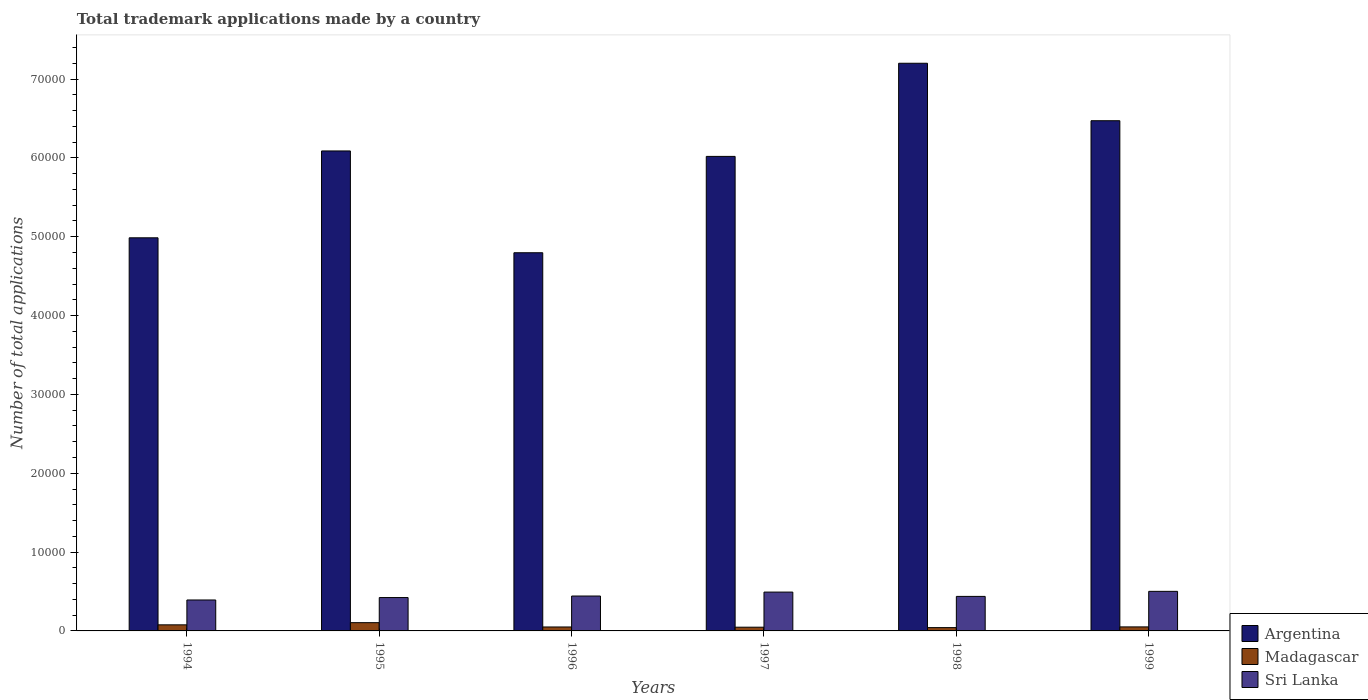How many groups of bars are there?
Make the answer very short. 6. Are the number of bars per tick equal to the number of legend labels?
Your answer should be very brief. Yes. Are the number of bars on each tick of the X-axis equal?
Provide a short and direct response. Yes. How many bars are there on the 2nd tick from the left?
Give a very brief answer. 3. What is the label of the 5th group of bars from the left?
Offer a terse response. 1998. In how many cases, is the number of bars for a given year not equal to the number of legend labels?
Your answer should be very brief. 0. Across all years, what is the maximum number of applications made by in Argentina?
Keep it short and to the point. 7.20e+04. Across all years, what is the minimum number of applications made by in Madagascar?
Ensure brevity in your answer.  420. In which year was the number of applications made by in Sri Lanka minimum?
Your response must be concise. 1994. What is the total number of applications made by in Argentina in the graph?
Your answer should be compact. 3.56e+05. What is the difference between the number of applications made by in Sri Lanka in 1994 and that in 1997?
Make the answer very short. -1001. What is the difference between the number of applications made by in Sri Lanka in 1994 and the number of applications made by in Madagascar in 1995?
Your answer should be compact. 2877. What is the average number of applications made by in Madagascar per year?
Keep it short and to the point. 620.33. In the year 1994, what is the difference between the number of applications made by in Sri Lanka and number of applications made by in Madagascar?
Offer a terse response. 3154. In how many years, is the number of applications made by in Madagascar greater than 48000?
Ensure brevity in your answer.  0. What is the ratio of the number of applications made by in Argentina in 1996 to that in 1998?
Make the answer very short. 0.67. Is the number of applications made by in Sri Lanka in 1997 less than that in 1998?
Provide a succinct answer. No. Is the difference between the number of applications made by in Sri Lanka in 1995 and 1996 greater than the difference between the number of applications made by in Madagascar in 1995 and 1996?
Your response must be concise. No. What is the difference between the highest and the second highest number of applications made by in Argentina?
Give a very brief answer. 7289. What is the difference between the highest and the lowest number of applications made by in Argentina?
Make the answer very short. 2.40e+04. In how many years, is the number of applications made by in Sri Lanka greater than the average number of applications made by in Sri Lanka taken over all years?
Your answer should be compact. 2. Is the sum of the number of applications made by in Sri Lanka in 1998 and 1999 greater than the maximum number of applications made by in Argentina across all years?
Offer a very short reply. No. What does the 3rd bar from the left in 1999 represents?
Your response must be concise. Sri Lanka. What does the 1st bar from the right in 1995 represents?
Offer a very short reply. Sri Lanka. Are the values on the major ticks of Y-axis written in scientific E-notation?
Ensure brevity in your answer.  No. Does the graph contain any zero values?
Your response must be concise. No. What is the title of the graph?
Make the answer very short. Total trademark applications made by a country. What is the label or title of the X-axis?
Provide a succinct answer. Years. What is the label or title of the Y-axis?
Your answer should be compact. Number of total applications. What is the Number of total applications of Argentina in 1994?
Keep it short and to the point. 4.99e+04. What is the Number of total applications of Madagascar in 1994?
Provide a succinct answer. 771. What is the Number of total applications of Sri Lanka in 1994?
Ensure brevity in your answer.  3925. What is the Number of total applications in Argentina in 1995?
Your answer should be very brief. 6.09e+04. What is the Number of total applications of Madagascar in 1995?
Keep it short and to the point. 1048. What is the Number of total applications of Sri Lanka in 1995?
Your answer should be compact. 4233. What is the Number of total applications of Argentina in 1996?
Provide a short and direct response. 4.80e+04. What is the Number of total applications of Sri Lanka in 1996?
Keep it short and to the point. 4427. What is the Number of total applications in Argentina in 1997?
Your answer should be compact. 6.02e+04. What is the Number of total applications of Madagascar in 1997?
Your answer should be compact. 473. What is the Number of total applications of Sri Lanka in 1997?
Give a very brief answer. 4926. What is the Number of total applications of Argentina in 1998?
Keep it short and to the point. 7.20e+04. What is the Number of total applications in Madagascar in 1998?
Offer a very short reply. 420. What is the Number of total applications of Sri Lanka in 1998?
Your response must be concise. 4379. What is the Number of total applications of Argentina in 1999?
Provide a succinct answer. 6.47e+04. What is the Number of total applications of Madagascar in 1999?
Provide a succinct answer. 510. What is the Number of total applications of Sri Lanka in 1999?
Make the answer very short. 5020. Across all years, what is the maximum Number of total applications in Argentina?
Your answer should be compact. 7.20e+04. Across all years, what is the maximum Number of total applications of Madagascar?
Your response must be concise. 1048. Across all years, what is the maximum Number of total applications of Sri Lanka?
Your answer should be very brief. 5020. Across all years, what is the minimum Number of total applications in Argentina?
Provide a succinct answer. 4.80e+04. Across all years, what is the minimum Number of total applications in Madagascar?
Your response must be concise. 420. Across all years, what is the minimum Number of total applications of Sri Lanka?
Your response must be concise. 3925. What is the total Number of total applications in Argentina in the graph?
Provide a succinct answer. 3.56e+05. What is the total Number of total applications of Madagascar in the graph?
Provide a succinct answer. 3722. What is the total Number of total applications in Sri Lanka in the graph?
Ensure brevity in your answer.  2.69e+04. What is the difference between the Number of total applications of Argentina in 1994 and that in 1995?
Provide a short and direct response. -1.10e+04. What is the difference between the Number of total applications of Madagascar in 1994 and that in 1995?
Your answer should be very brief. -277. What is the difference between the Number of total applications of Sri Lanka in 1994 and that in 1995?
Give a very brief answer. -308. What is the difference between the Number of total applications in Argentina in 1994 and that in 1996?
Your response must be concise. 1895. What is the difference between the Number of total applications in Madagascar in 1994 and that in 1996?
Offer a very short reply. 271. What is the difference between the Number of total applications in Sri Lanka in 1994 and that in 1996?
Ensure brevity in your answer.  -502. What is the difference between the Number of total applications in Argentina in 1994 and that in 1997?
Offer a very short reply. -1.03e+04. What is the difference between the Number of total applications in Madagascar in 1994 and that in 1997?
Keep it short and to the point. 298. What is the difference between the Number of total applications in Sri Lanka in 1994 and that in 1997?
Give a very brief answer. -1001. What is the difference between the Number of total applications in Argentina in 1994 and that in 1998?
Your answer should be very brief. -2.21e+04. What is the difference between the Number of total applications in Madagascar in 1994 and that in 1998?
Your answer should be very brief. 351. What is the difference between the Number of total applications in Sri Lanka in 1994 and that in 1998?
Offer a very short reply. -454. What is the difference between the Number of total applications in Argentina in 1994 and that in 1999?
Make the answer very short. -1.49e+04. What is the difference between the Number of total applications in Madagascar in 1994 and that in 1999?
Give a very brief answer. 261. What is the difference between the Number of total applications of Sri Lanka in 1994 and that in 1999?
Provide a succinct answer. -1095. What is the difference between the Number of total applications of Argentina in 1995 and that in 1996?
Give a very brief answer. 1.29e+04. What is the difference between the Number of total applications of Madagascar in 1995 and that in 1996?
Provide a short and direct response. 548. What is the difference between the Number of total applications in Sri Lanka in 1995 and that in 1996?
Make the answer very short. -194. What is the difference between the Number of total applications in Argentina in 1995 and that in 1997?
Your answer should be compact. 690. What is the difference between the Number of total applications of Madagascar in 1995 and that in 1997?
Offer a terse response. 575. What is the difference between the Number of total applications of Sri Lanka in 1995 and that in 1997?
Offer a very short reply. -693. What is the difference between the Number of total applications of Argentina in 1995 and that in 1998?
Offer a terse response. -1.11e+04. What is the difference between the Number of total applications of Madagascar in 1995 and that in 1998?
Your response must be concise. 628. What is the difference between the Number of total applications of Sri Lanka in 1995 and that in 1998?
Provide a short and direct response. -146. What is the difference between the Number of total applications of Argentina in 1995 and that in 1999?
Your answer should be compact. -3835. What is the difference between the Number of total applications of Madagascar in 1995 and that in 1999?
Keep it short and to the point. 538. What is the difference between the Number of total applications of Sri Lanka in 1995 and that in 1999?
Give a very brief answer. -787. What is the difference between the Number of total applications of Argentina in 1996 and that in 1997?
Offer a terse response. -1.22e+04. What is the difference between the Number of total applications in Madagascar in 1996 and that in 1997?
Provide a succinct answer. 27. What is the difference between the Number of total applications of Sri Lanka in 1996 and that in 1997?
Your answer should be very brief. -499. What is the difference between the Number of total applications of Argentina in 1996 and that in 1998?
Provide a succinct answer. -2.40e+04. What is the difference between the Number of total applications of Argentina in 1996 and that in 1999?
Provide a succinct answer. -1.67e+04. What is the difference between the Number of total applications in Sri Lanka in 1996 and that in 1999?
Make the answer very short. -593. What is the difference between the Number of total applications of Argentina in 1997 and that in 1998?
Provide a short and direct response. -1.18e+04. What is the difference between the Number of total applications of Sri Lanka in 1997 and that in 1998?
Your response must be concise. 547. What is the difference between the Number of total applications of Argentina in 1997 and that in 1999?
Make the answer very short. -4525. What is the difference between the Number of total applications of Madagascar in 1997 and that in 1999?
Your answer should be very brief. -37. What is the difference between the Number of total applications in Sri Lanka in 1997 and that in 1999?
Your response must be concise. -94. What is the difference between the Number of total applications in Argentina in 1998 and that in 1999?
Offer a terse response. 7289. What is the difference between the Number of total applications of Madagascar in 1998 and that in 1999?
Make the answer very short. -90. What is the difference between the Number of total applications of Sri Lanka in 1998 and that in 1999?
Offer a very short reply. -641. What is the difference between the Number of total applications in Argentina in 1994 and the Number of total applications in Madagascar in 1995?
Offer a very short reply. 4.88e+04. What is the difference between the Number of total applications in Argentina in 1994 and the Number of total applications in Sri Lanka in 1995?
Make the answer very short. 4.56e+04. What is the difference between the Number of total applications in Madagascar in 1994 and the Number of total applications in Sri Lanka in 1995?
Offer a terse response. -3462. What is the difference between the Number of total applications of Argentina in 1994 and the Number of total applications of Madagascar in 1996?
Offer a terse response. 4.94e+04. What is the difference between the Number of total applications in Argentina in 1994 and the Number of total applications in Sri Lanka in 1996?
Your answer should be very brief. 4.54e+04. What is the difference between the Number of total applications of Madagascar in 1994 and the Number of total applications of Sri Lanka in 1996?
Offer a very short reply. -3656. What is the difference between the Number of total applications of Argentina in 1994 and the Number of total applications of Madagascar in 1997?
Ensure brevity in your answer.  4.94e+04. What is the difference between the Number of total applications of Argentina in 1994 and the Number of total applications of Sri Lanka in 1997?
Provide a short and direct response. 4.49e+04. What is the difference between the Number of total applications in Madagascar in 1994 and the Number of total applications in Sri Lanka in 1997?
Offer a terse response. -4155. What is the difference between the Number of total applications of Argentina in 1994 and the Number of total applications of Madagascar in 1998?
Keep it short and to the point. 4.94e+04. What is the difference between the Number of total applications in Argentina in 1994 and the Number of total applications in Sri Lanka in 1998?
Your answer should be very brief. 4.55e+04. What is the difference between the Number of total applications in Madagascar in 1994 and the Number of total applications in Sri Lanka in 1998?
Your answer should be compact. -3608. What is the difference between the Number of total applications in Argentina in 1994 and the Number of total applications in Madagascar in 1999?
Keep it short and to the point. 4.94e+04. What is the difference between the Number of total applications of Argentina in 1994 and the Number of total applications of Sri Lanka in 1999?
Make the answer very short. 4.48e+04. What is the difference between the Number of total applications in Madagascar in 1994 and the Number of total applications in Sri Lanka in 1999?
Keep it short and to the point. -4249. What is the difference between the Number of total applications of Argentina in 1995 and the Number of total applications of Madagascar in 1996?
Provide a short and direct response. 6.04e+04. What is the difference between the Number of total applications in Argentina in 1995 and the Number of total applications in Sri Lanka in 1996?
Keep it short and to the point. 5.65e+04. What is the difference between the Number of total applications of Madagascar in 1995 and the Number of total applications of Sri Lanka in 1996?
Offer a very short reply. -3379. What is the difference between the Number of total applications in Argentina in 1995 and the Number of total applications in Madagascar in 1997?
Offer a very short reply. 6.04e+04. What is the difference between the Number of total applications in Argentina in 1995 and the Number of total applications in Sri Lanka in 1997?
Offer a very short reply. 5.60e+04. What is the difference between the Number of total applications in Madagascar in 1995 and the Number of total applications in Sri Lanka in 1997?
Ensure brevity in your answer.  -3878. What is the difference between the Number of total applications of Argentina in 1995 and the Number of total applications of Madagascar in 1998?
Give a very brief answer. 6.05e+04. What is the difference between the Number of total applications of Argentina in 1995 and the Number of total applications of Sri Lanka in 1998?
Keep it short and to the point. 5.65e+04. What is the difference between the Number of total applications of Madagascar in 1995 and the Number of total applications of Sri Lanka in 1998?
Ensure brevity in your answer.  -3331. What is the difference between the Number of total applications in Argentina in 1995 and the Number of total applications in Madagascar in 1999?
Your answer should be compact. 6.04e+04. What is the difference between the Number of total applications of Argentina in 1995 and the Number of total applications of Sri Lanka in 1999?
Provide a succinct answer. 5.59e+04. What is the difference between the Number of total applications of Madagascar in 1995 and the Number of total applications of Sri Lanka in 1999?
Give a very brief answer. -3972. What is the difference between the Number of total applications of Argentina in 1996 and the Number of total applications of Madagascar in 1997?
Your response must be concise. 4.75e+04. What is the difference between the Number of total applications in Argentina in 1996 and the Number of total applications in Sri Lanka in 1997?
Keep it short and to the point. 4.30e+04. What is the difference between the Number of total applications of Madagascar in 1996 and the Number of total applications of Sri Lanka in 1997?
Provide a succinct answer. -4426. What is the difference between the Number of total applications in Argentina in 1996 and the Number of total applications in Madagascar in 1998?
Keep it short and to the point. 4.76e+04. What is the difference between the Number of total applications of Argentina in 1996 and the Number of total applications of Sri Lanka in 1998?
Provide a short and direct response. 4.36e+04. What is the difference between the Number of total applications in Madagascar in 1996 and the Number of total applications in Sri Lanka in 1998?
Offer a very short reply. -3879. What is the difference between the Number of total applications of Argentina in 1996 and the Number of total applications of Madagascar in 1999?
Provide a short and direct response. 4.75e+04. What is the difference between the Number of total applications in Argentina in 1996 and the Number of total applications in Sri Lanka in 1999?
Give a very brief answer. 4.30e+04. What is the difference between the Number of total applications in Madagascar in 1996 and the Number of total applications in Sri Lanka in 1999?
Your answer should be compact. -4520. What is the difference between the Number of total applications in Argentina in 1997 and the Number of total applications in Madagascar in 1998?
Your answer should be very brief. 5.98e+04. What is the difference between the Number of total applications in Argentina in 1997 and the Number of total applications in Sri Lanka in 1998?
Offer a very short reply. 5.58e+04. What is the difference between the Number of total applications in Madagascar in 1997 and the Number of total applications in Sri Lanka in 1998?
Your response must be concise. -3906. What is the difference between the Number of total applications of Argentina in 1997 and the Number of total applications of Madagascar in 1999?
Offer a terse response. 5.97e+04. What is the difference between the Number of total applications of Argentina in 1997 and the Number of total applications of Sri Lanka in 1999?
Keep it short and to the point. 5.52e+04. What is the difference between the Number of total applications of Madagascar in 1997 and the Number of total applications of Sri Lanka in 1999?
Your answer should be very brief. -4547. What is the difference between the Number of total applications in Argentina in 1998 and the Number of total applications in Madagascar in 1999?
Offer a terse response. 7.15e+04. What is the difference between the Number of total applications in Argentina in 1998 and the Number of total applications in Sri Lanka in 1999?
Ensure brevity in your answer.  6.70e+04. What is the difference between the Number of total applications in Madagascar in 1998 and the Number of total applications in Sri Lanka in 1999?
Give a very brief answer. -4600. What is the average Number of total applications in Argentina per year?
Give a very brief answer. 5.93e+04. What is the average Number of total applications of Madagascar per year?
Provide a succinct answer. 620.33. What is the average Number of total applications of Sri Lanka per year?
Your answer should be compact. 4485. In the year 1994, what is the difference between the Number of total applications in Argentina and Number of total applications in Madagascar?
Give a very brief answer. 4.91e+04. In the year 1994, what is the difference between the Number of total applications in Argentina and Number of total applications in Sri Lanka?
Give a very brief answer. 4.59e+04. In the year 1994, what is the difference between the Number of total applications in Madagascar and Number of total applications in Sri Lanka?
Your answer should be compact. -3154. In the year 1995, what is the difference between the Number of total applications of Argentina and Number of total applications of Madagascar?
Offer a terse response. 5.98e+04. In the year 1995, what is the difference between the Number of total applications of Argentina and Number of total applications of Sri Lanka?
Keep it short and to the point. 5.67e+04. In the year 1995, what is the difference between the Number of total applications in Madagascar and Number of total applications in Sri Lanka?
Make the answer very short. -3185. In the year 1996, what is the difference between the Number of total applications of Argentina and Number of total applications of Madagascar?
Offer a very short reply. 4.75e+04. In the year 1996, what is the difference between the Number of total applications in Argentina and Number of total applications in Sri Lanka?
Keep it short and to the point. 4.35e+04. In the year 1996, what is the difference between the Number of total applications of Madagascar and Number of total applications of Sri Lanka?
Make the answer very short. -3927. In the year 1997, what is the difference between the Number of total applications in Argentina and Number of total applications in Madagascar?
Your response must be concise. 5.97e+04. In the year 1997, what is the difference between the Number of total applications of Argentina and Number of total applications of Sri Lanka?
Your answer should be very brief. 5.53e+04. In the year 1997, what is the difference between the Number of total applications in Madagascar and Number of total applications in Sri Lanka?
Your answer should be compact. -4453. In the year 1998, what is the difference between the Number of total applications in Argentina and Number of total applications in Madagascar?
Give a very brief answer. 7.16e+04. In the year 1998, what is the difference between the Number of total applications of Argentina and Number of total applications of Sri Lanka?
Offer a very short reply. 6.76e+04. In the year 1998, what is the difference between the Number of total applications in Madagascar and Number of total applications in Sri Lanka?
Your answer should be very brief. -3959. In the year 1999, what is the difference between the Number of total applications in Argentina and Number of total applications in Madagascar?
Provide a short and direct response. 6.42e+04. In the year 1999, what is the difference between the Number of total applications in Argentina and Number of total applications in Sri Lanka?
Provide a succinct answer. 5.97e+04. In the year 1999, what is the difference between the Number of total applications of Madagascar and Number of total applications of Sri Lanka?
Your answer should be compact. -4510. What is the ratio of the Number of total applications of Argentina in 1994 to that in 1995?
Ensure brevity in your answer.  0.82. What is the ratio of the Number of total applications in Madagascar in 1994 to that in 1995?
Offer a terse response. 0.74. What is the ratio of the Number of total applications in Sri Lanka in 1994 to that in 1995?
Ensure brevity in your answer.  0.93. What is the ratio of the Number of total applications of Argentina in 1994 to that in 1996?
Provide a succinct answer. 1.04. What is the ratio of the Number of total applications of Madagascar in 1994 to that in 1996?
Keep it short and to the point. 1.54. What is the ratio of the Number of total applications of Sri Lanka in 1994 to that in 1996?
Your answer should be compact. 0.89. What is the ratio of the Number of total applications in Argentina in 1994 to that in 1997?
Offer a terse response. 0.83. What is the ratio of the Number of total applications of Madagascar in 1994 to that in 1997?
Give a very brief answer. 1.63. What is the ratio of the Number of total applications in Sri Lanka in 1994 to that in 1997?
Your answer should be very brief. 0.8. What is the ratio of the Number of total applications of Argentina in 1994 to that in 1998?
Make the answer very short. 0.69. What is the ratio of the Number of total applications of Madagascar in 1994 to that in 1998?
Provide a short and direct response. 1.84. What is the ratio of the Number of total applications of Sri Lanka in 1994 to that in 1998?
Make the answer very short. 0.9. What is the ratio of the Number of total applications in Argentina in 1994 to that in 1999?
Ensure brevity in your answer.  0.77. What is the ratio of the Number of total applications in Madagascar in 1994 to that in 1999?
Your answer should be very brief. 1.51. What is the ratio of the Number of total applications in Sri Lanka in 1994 to that in 1999?
Your answer should be compact. 0.78. What is the ratio of the Number of total applications in Argentina in 1995 to that in 1996?
Make the answer very short. 1.27. What is the ratio of the Number of total applications of Madagascar in 1995 to that in 1996?
Provide a succinct answer. 2.1. What is the ratio of the Number of total applications in Sri Lanka in 1995 to that in 1996?
Ensure brevity in your answer.  0.96. What is the ratio of the Number of total applications in Argentina in 1995 to that in 1997?
Keep it short and to the point. 1.01. What is the ratio of the Number of total applications in Madagascar in 1995 to that in 1997?
Offer a terse response. 2.22. What is the ratio of the Number of total applications in Sri Lanka in 1995 to that in 1997?
Give a very brief answer. 0.86. What is the ratio of the Number of total applications of Argentina in 1995 to that in 1998?
Your response must be concise. 0.85. What is the ratio of the Number of total applications in Madagascar in 1995 to that in 1998?
Your response must be concise. 2.5. What is the ratio of the Number of total applications in Sri Lanka in 1995 to that in 1998?
Ensure brevity in your answer.  0.97. What is the ratio of the Number of total applications of Argentina in 1995 to that in 1999?
Provide a short and direct response. 0.94. What is the ratio of the Number of total applications in Madagascar in 1995 to that in 1999?
Offer a very short reply. 2.05. What is the ratio of the Number of total applications in Sri Lanka in 1995 to that in 1999?
Your answer should be compact. 0.84. What is the ratio of the Number of total applications of Argentina in 1996 to that in 1997?
Your response must be concise. 0.8. What is the ratio of the Number of total applications in Madagascar in 1996 to that in 1997?
Your response must be concise. 1.06. What is the ratio of the Number of total applications of Sri Lanka in 1996 to that in 1997?
Your response must be concise. 0.9. What is the ratio of the Number of total applications in Argentina in 1996 to that in 1998?
Your answer should be very brief. 0.67. What is the ratio of the Number of total applications in Madagascar in 1996 to that in 1998?
Your answer should be compact. 1.19. What is the ratio of the Number of total applications in Sri Lanka in 1996 to that in 1998?
Offer a very short reply. 1.01. What is the ratio of the Number of total applications of Argentina in 1996 to that in 1999?
Offer a very short reply. 0.74. What is the ratio of the Number of total applications of Madagascar in 1996 to that in 1999?
Offer a terse response. 0.98. What is the ratio of the Number of total applications of Sri Lanka in 1996 to that in 1999?
Your response must be concise. 0.88. What is the ratio of the Number of total applications of Argentina in 1997 to that in 1998?
Give a very brief answer. 0.84. What is the ratio of the Number of total applications in Madagascar in 1997 to that in 1998?
Provide a short and direct response. 1.13. What is the ratio of the Number of total applications in Sri Lanka in 1997 to that in 1998?
Ensure brevity in your answer.  1.12. What is the ratio of the Number of total applications of Argentina in 1997 to that in 1999?
Keep it short and to the point. 0.93. What is the ratio of the Number of total applications of Madagascar in 1997 to that in 1999?
Make the answer very short. 0.93. What is the ratio of the Number of total applications of Sri Lanka in 1997 to that in 1999?
Provide a short and direct response. 0.98. What is the ratio of the Number of total applications in Argentina in 1998 to that in 1999?
Your answer should be compact. 1.11. What is the ratio of the Number of total applications in Madagascar in 1998 to that in 1999?
Your response must be concise. 0.82. What is the ratio of the Number of total applications of Sri Lanka in 1998 to that in 1999?
Provide a succinct answer. 0.87. What is the difference between the highest and the second highest Number of total applications in Argentina?
Ensure brevity in your answer.  7289. What is the difference between the highest and the second highest Number of total applications in Madagascar?
Your answer should be compact. 277. What is the difference between the highest and the second highest Number of total applications of Sri Lanka?
Make the answer very short. 94. What is the difference between the highest and the lowest Number of total applications in Argentina?
Your answer should be very brief. 2.40e+04. What is the difference between the highest and the lowest Number of total applications in Madagascar?
Provide a succinct answer. 628. What is the difference between the highest and the lowest Number of total applications of Sri Lanka?
Your response must be concise. 1095. 